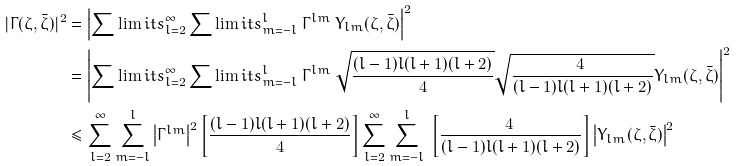<formula> <loc_0><loc_0><loc_500><loc_500>| \Gamma ( \zeta , \bar { \zeta } ) | ^ { 2 } & = \left | \sum \lim i t s _ { l = 2 } ^ { \infty } \sum \lim i t s _ { m = - l } ^ { l } \ \Gamma ^ { l m } \ Y _ { l m } ( \zeta , \bar { \zeta } ) \right | ^ { 2 } \\ & = \left | \sum \lim i t s _ { l = 2 } ^ { \infty } \sum \lim i t s _ { m = - l } ^ { l } \ \Gamma ^ { l m } \ \sqrt { \frac { ( l - 1 ) l ( l + 1 ) ( l + 2 ) } { 4 } } \sqrt { \frac { 4 \ } { ( l - 1 ) l ( l + 1 ) ( l + 2 ) } } Y _ { l m } ( \zeta , \bar { \zeta } ) \right | ^ { 2 } \\ & \leq \sum _ { l = 2 } ^ { \infty } \sum _ { m = - l } ^ { l } \left | \Gamma ^ { l m } \right | ^ { 2 } \left [ \frac { ( l - 1 ) l ( l + 1 ) ( l + 2 ) } { 4 } \right ] \sum _ { l = 2 } ^ { \infty } \sum _ { m = - l } ^ { l } \ \left [ \frac { 4 \ } { ( l - 1 ) l ( l + 1 ) ( l + 2 ) } \right ] \left | Y _ { l m } ( \zeta , \bar { \zeta } ) \right | ^ { 2 }</formula> 